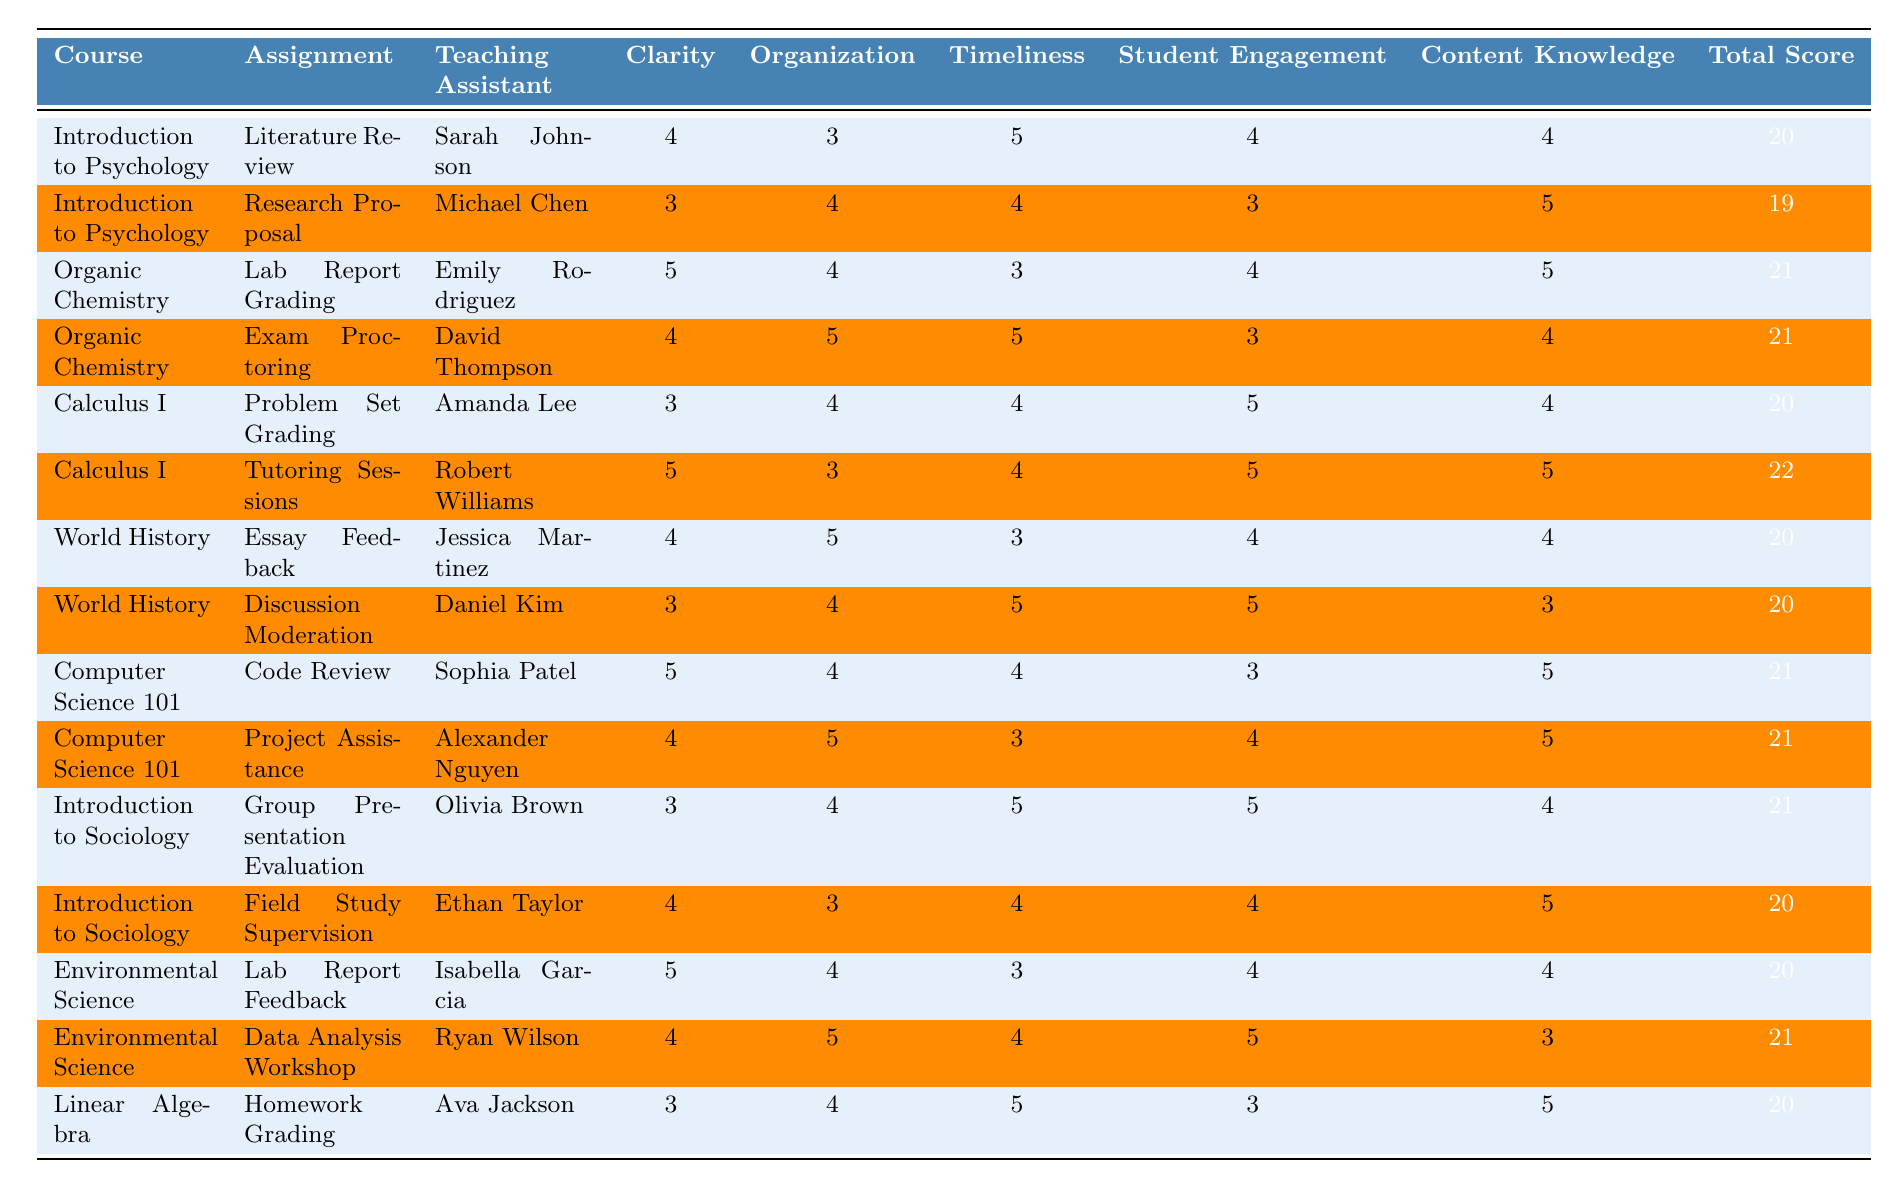What is the total score for the "Lab Report Grading" assignment in Organic Chemistry? By looking at the table, we find the row corresponding to "Lab Report Grading" under "Organic Chemistry" and see that the total score listed is 21.
Answer: 21 Who was the Teaching Assistant for the "Research Proposal" assignment? The table specifies that the "Research Proposal" assignment is under "Introduction to Psychology," and the Teaching Assistant listed for that assignment is Michael Chen.
Answer: Michael Chen Which assignment had the highest total score? To determine the assignment with the highest total score, we need to compare the total scores in the table. The highest score is 22, achieved by "Tutoring Sessions" under "Calculus I."
Answer: Tutoring Sessions What is the average total score of all assignments? First, we add all the total scores from the table (20 + 19 + 21 + 21 + 20 + 22 + 20 + 20 + 21 + 21 + 21 + 20 + 20 + 21 + 20 = 309). There are 15 assignments, so the average is 309 / 15 = 20.6.
Answer: 20.6 Do any assignments have a total score of 19? We check the table for any total score of 19. The "Research Proposal" under "Introduction to Psychology" has a total score of 19. Therefore, the answer is yes.
Answer: Yes Which Teaching Assistant scored the highest for "Student Engagement"? To answer this, we look at the "Student Engagement" column and find the highest score of 5. This score is achieved by Robert Williams in "Tutoring Sessions" and several others, but he is one of the Teaching Assistants.
Answer: Robert Williams How many assignments were graded by Sarah Johnson? By examining the entries under the "Teaching Assistant" column, we count the rows where Sarah Johnson is listed. She is credited with one assignment only: "Literature Review."
Answer: 1 What is the difference between the highest and lowest total scores? The highest total score is 22 (from "Tutoring Sessions"), and the lowest is 19 (from "Research Proposal"). The difference is 22 - 19 = 3.
Answer: 3 Which course had the most assignments graded? We analyze the "Course" column and count the assignments for each course. "Organic Chemistry" has 2 assignments, "Calculus I" has 2 assignments, and the rest have either 1 or 2. Therefore, all courses have an equal maximum of 2 assignments.
Answer: Tie between multiple courses Is there any assignment with all categories scored at 5? We review each row for scores of 5 in all categories. None of the assignments have 5s across all criteria, so the answer is no.
Answer: No How does Emily Rodriguez's clarity score compare to the total score of any other Teaching Assistant in the Organic Chemistry course? Emily Rodriguez scored 5 for clarity in her assignment. The other Teaching Assistant, David Thompson, scored 4 for clarity. Since her score of 5 is higher, Emily's clarity score is better than David's.
Answer: Better than David Thompson 